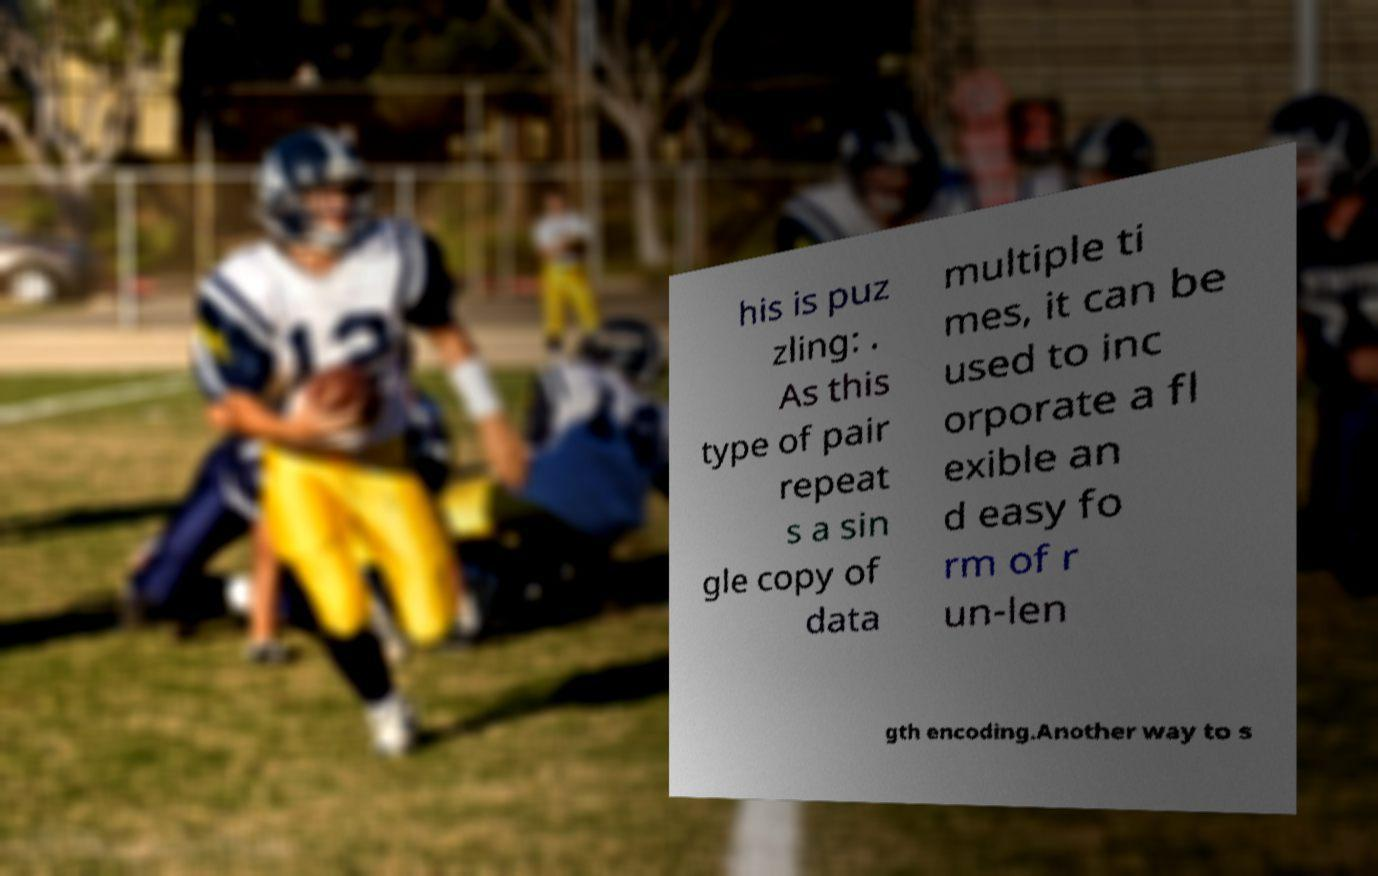There's text embedded in this image that I need extracted. Can you transcribe it verbatim? his is puz zling: . As this type of pair repeat s a sin gle copy of data multiple ti mes, it can be used to inc orporate a fl exible an d easy fo rm of r un-len gth encoding.Another way to s 